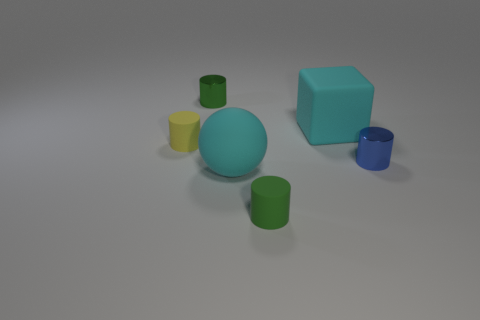Add 3 blue shiny objects. How many objects exist? 9 Subtract all cylinders. How many objects are left? 2 Subtract all yellow things. Subtract all small green matte cylinders. How many objects are left? 4 Add 6 blue shiny things. How many blue shiny things are left? 7 Add 6 gray rubber cubes. How many gray rubber cubes exist? 6 Subtract 0 purple balls. How many objects are left? 6 